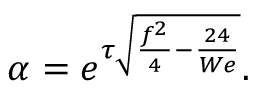Convert formula to latex. <formula><loc_0><loc_0><loc_500><loc_500>\alpha = e ^ { \tau \sqrt { \frac { f ^ { 2 } } { 4 } - \frac { 2 4 } { W e } } } .</formula> 